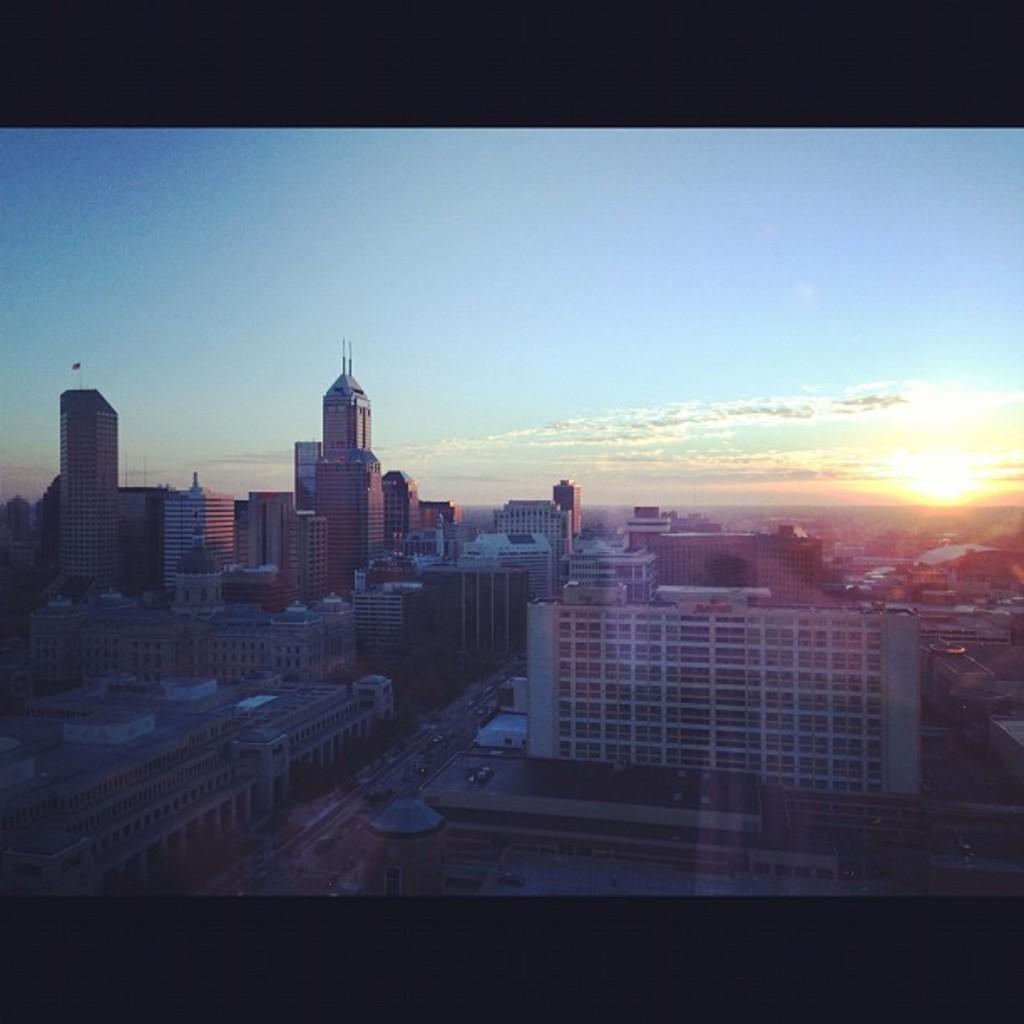In one or two sentences, can you explain what this image depicts? In the center of the image buildings are there. At the bottom of the image we can see road, cars, vehicles are there. At the top of the image clouds are present in the sky. On the right side of the image sun is there. 